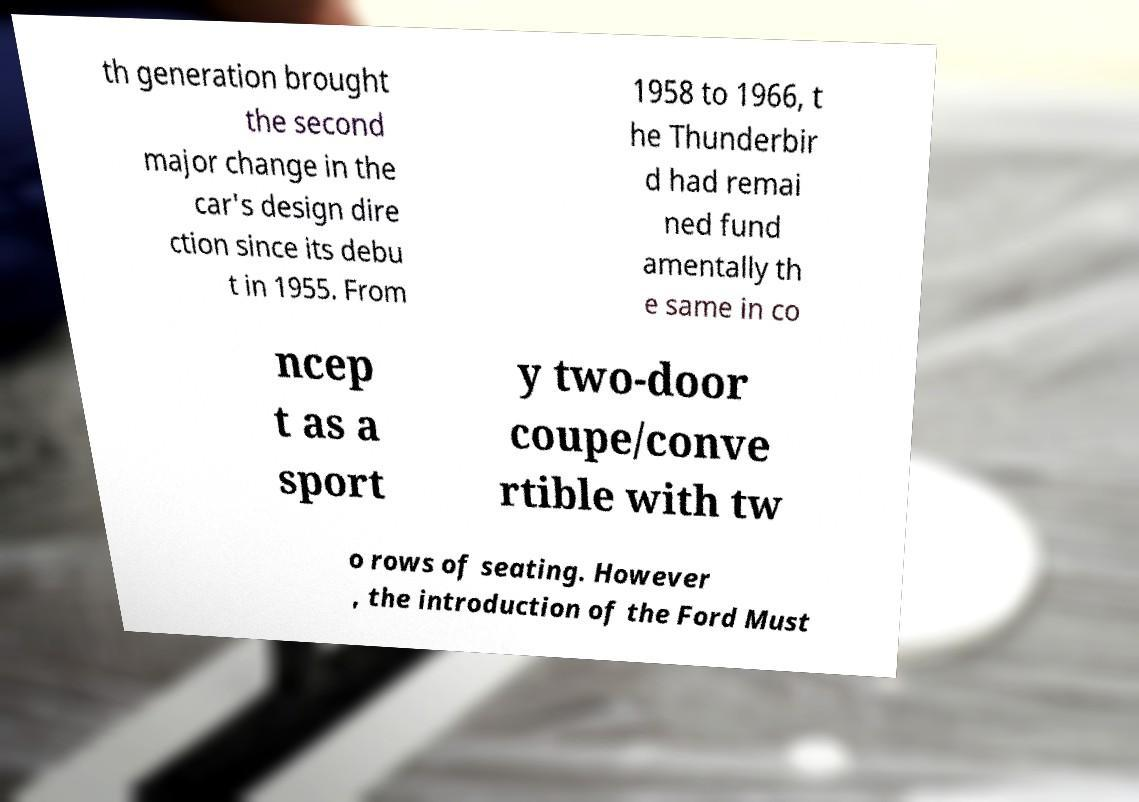What messages or text are displayed in this image? I need them in a readable, typed format. th generation brought the second major change in the car's design dire ction since its debu t in 1955. From 1958 to 1966, t he Thunderbir d had remai ned fund amentally th e same in co ncep t as a sport y two-door coupe/conve rtible with tw o rows of seating. However , the introduction of the Ford Must 